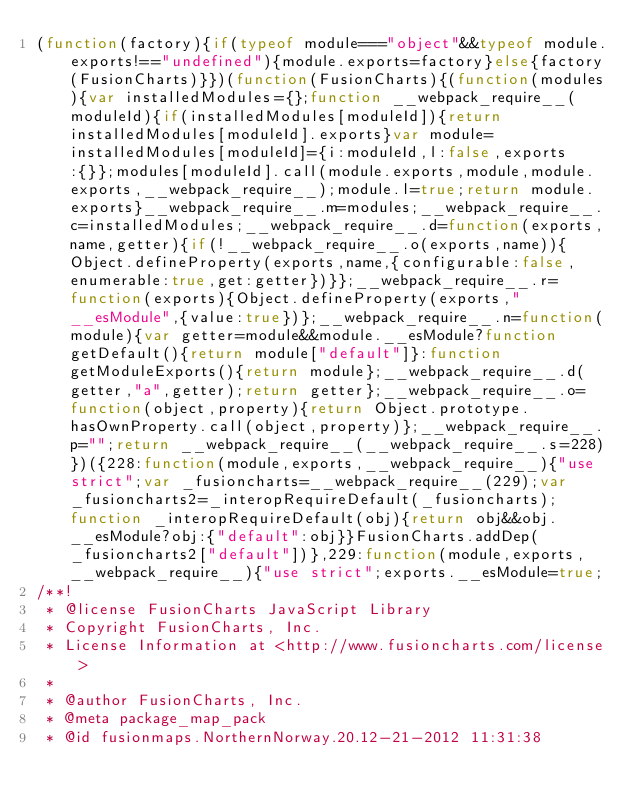<code> <loc_0><loc_0><loc_500><loc_500><_JavaScript_>(function(factory){if(typeof module==="object"&&typeof module.exports!=="undefined"){module.exports=factory}else{factory(FusionCharts)}})(function(FusionCharts){(function(modules){var installedModules={};function __webpack_require__(moduleId){if(installedModules[moduleId]){return installedModules[moduleId].exports}var module=installedModules[moduleId]={i:moduleId,l:false,exports:{}};modules[moduleId].call(module.exports,module,module.exports,__webpack_require__);module.l=true;return module.exports}__webpack_require__.m=modules;__webpack_require__.c=installedModules;__webpack_require__.d=function(exports,name,getter){if(!__webpack_require__.o(exports,name)){Object.defineProperty(exports,name,{configurable:false,enumerable:true,get:getter})}};__webpack_require__.r=function(exports){Object.defineProperty(exports,"__esModule",{value:true})};__webpack_require__.n=function(module){var getter=module&&module.__esModule?function getDefault(){return module["default"]}:function getModuleExports(){return module};__webpack_require__.d(getter,"a",getter);return getter};__webpack_require__.o=function(object,property){return Object.prototype.hasOwnProperty.call(object,property)};__webpack_require__.p="";return __webpack_require__(__webpack_require__.s=228)})({228:function(module,exports,__webpack_require__){"use strict";var _fusioncharts=__webpack_require__(229);var _fusioncharts2=_interopRequireDefault(_fusioncharts);function _interopRequireDefault(obj){return obj&&obj.__esModule?obj:{"default":obj}}FusionCharts.addDep(_fusioncharts2["default"])},229:function(module,exports,__webpack_require__){"use strict";exports.__esModule=true;
/**!
 * @license FusionCharts JavaScript Library
 * Copyright FusionCharts, Inc.
 * License Information at <http://www.fusioncharts.com/license>
 *
 * @author FusionCharts, Inc.
 * @meta package_map_pack
 * @id fusionmaps.NorthernNorway.20.12-21-2012 11:31:38</code> 